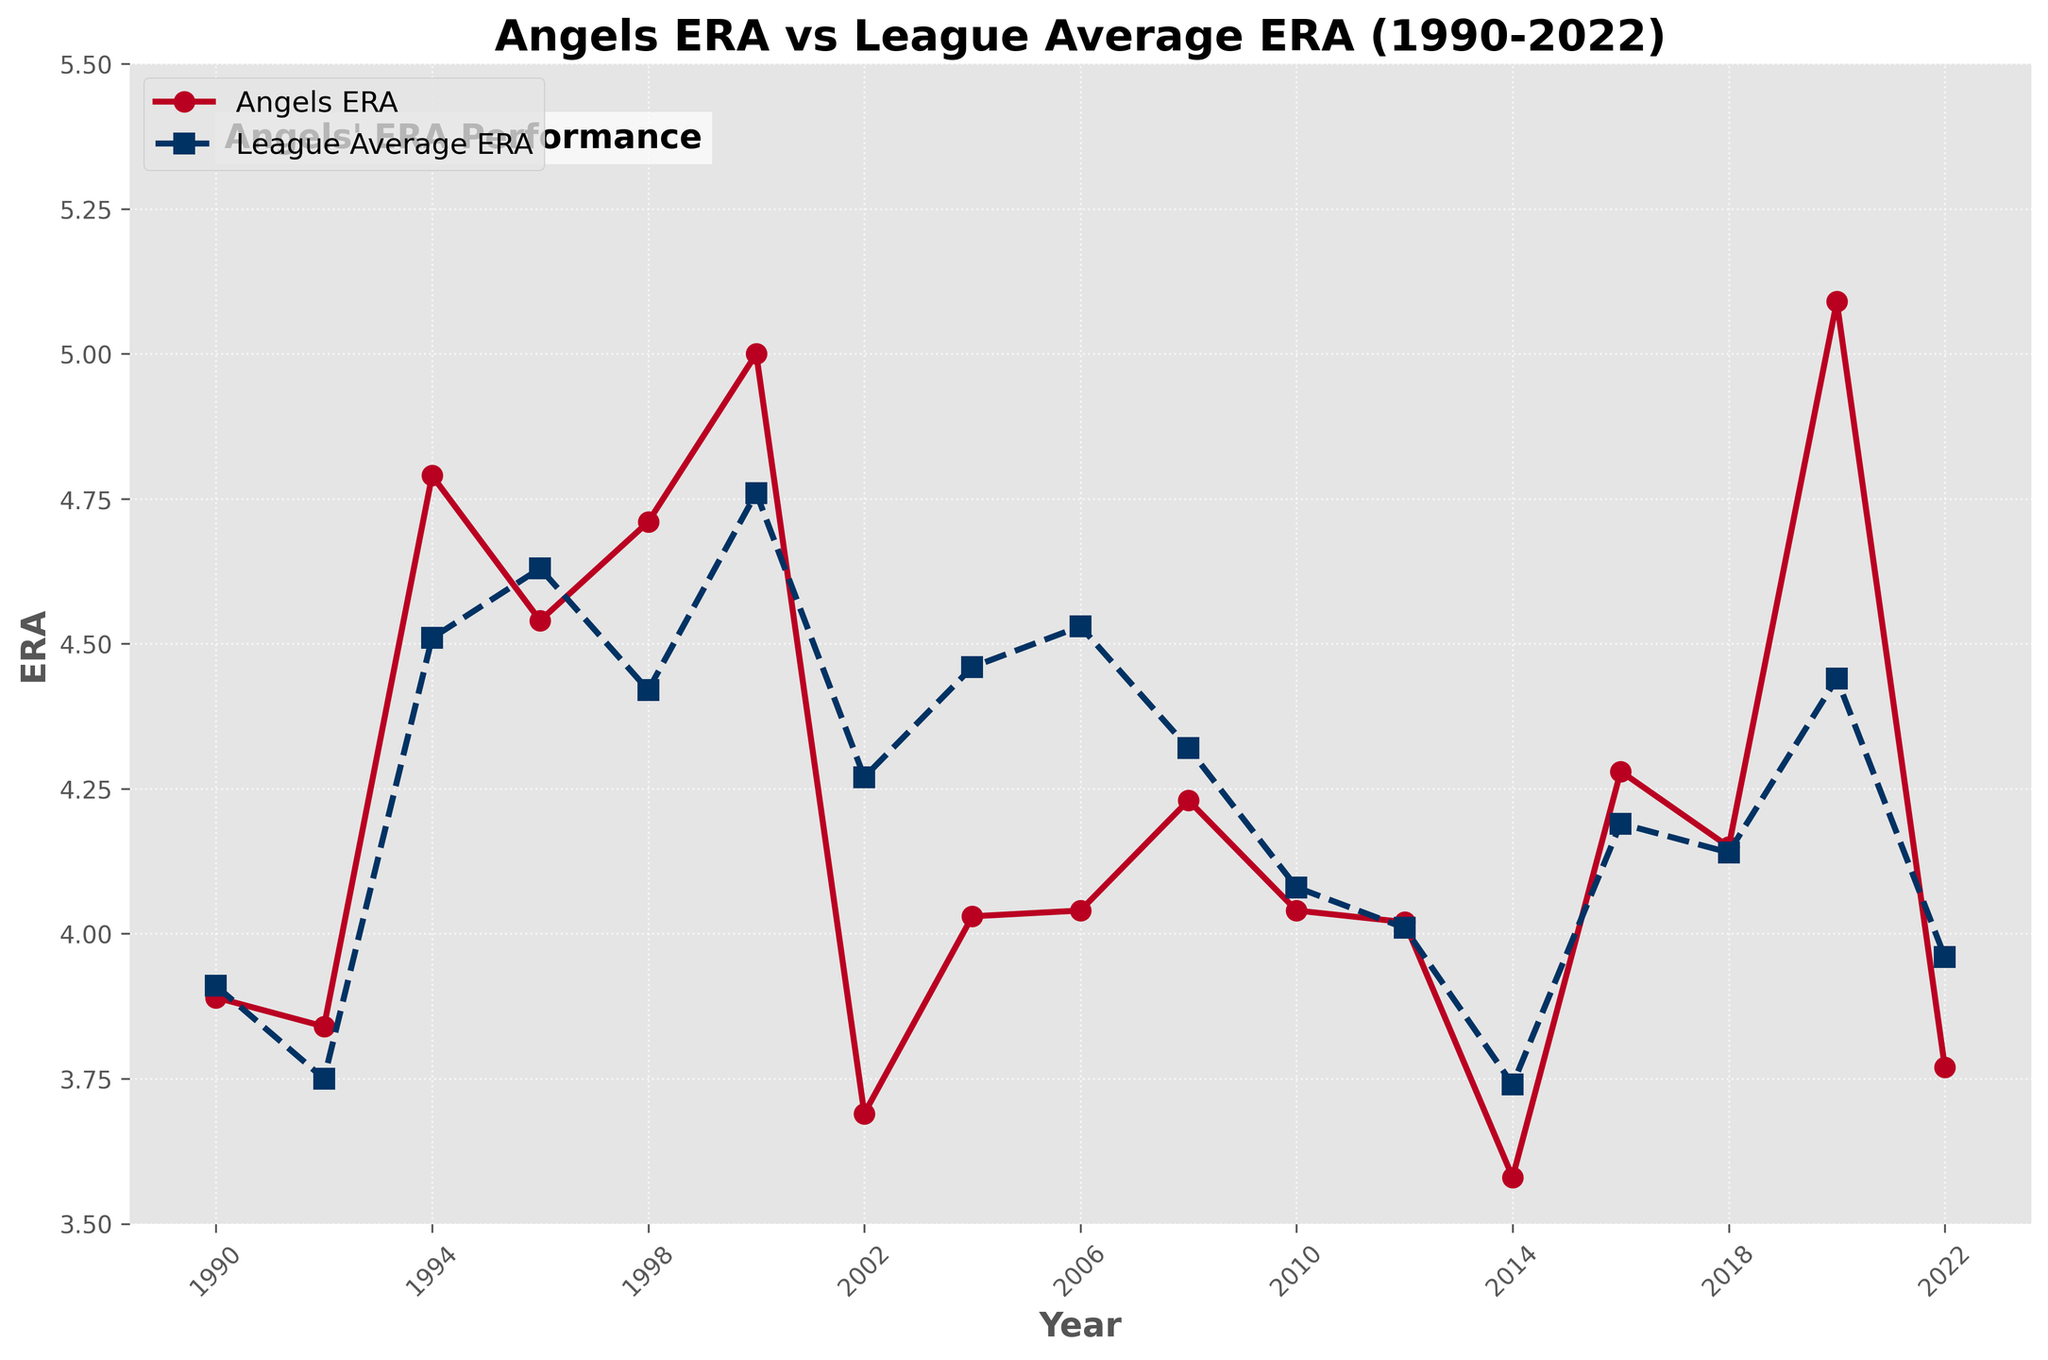What was the Angels' ERA in the year 2002? Locate the data point for the Angels' ERA on the line chart in the year 2002, which is represented by a red line with markers. The value indicated by this point is 3.69.
Answer: 3.69 How did the Angels' ERA in 1996 compare to the league average ERA in 1996? Identify the markers on both the Angels' ERA line and the league average ERA line for the year 1996. The Angels' ERA is 4.54, while the league average ERA is 4.63. The Angels' ERA was lower than the league average.
Answer: It was lower What is the difference between the Angels' ERA and the league average ERA in 2020? Look at the data points for 2020. The Angels' ERA is 5.09, and the league average ERA is 4.44. Calculate the difference between these two values: 5.09 - 4.44 = 0.65.
Answer: 0.65 In which year did the Angels' ERA drop below 4.00 after the year 2000? Check the data points on the chart for the Angels' ERA line for years after 2000. In 2002, the Angels' ERA dropped to 3.69, which is below 4.00.
Answer: 2002 Which year shows the closest ERA values between the Angels and the league average? Compare the differences between the Angles' ERA and League Average ERA for each year. In 2012, the differences are minimal with values of 4.02 and 4.01, respectively.
Answer: 2012 What color is used to represent the Angels' ERA on the chart? Observe the line color used for the Angels' ERA. The color used is red.
Answer: Red Is there any year where the Angels' ERA is consistently lower than the league average ERA? Evaluate each year individually by comparing the values on both ERA lines. The Angels' ERA is consistently lower than the League Average ERA from 2002 through 2022.
Answer: Yes, from 2002 to 2022 What is the average ERA of the Angels from the years 1990 to 2022? Sum up all the ERA values for the Angels over the years and divide by the number of years. Sum = 3.89 + 3.84 + 4.79 + 4.54 + 4.71 + 5.00 + 3.69 + 4.03 + 4.04 + 4.23 + 4.04 + 4.02 + 3.58 + 4.28 + 4.15 + 5.09 + 3.77 = 75.59, then divide by 17 years: 75.59 / 17 = 4.45.
Answer: 4.45 What is the highest ERA recorded by the Angels, and in which year did it occur? Identify the peak data point on the Angels' ERA line. The highest ERA recorded is 5.09 in the year 2020.
Answer: 5.09 in 2020 